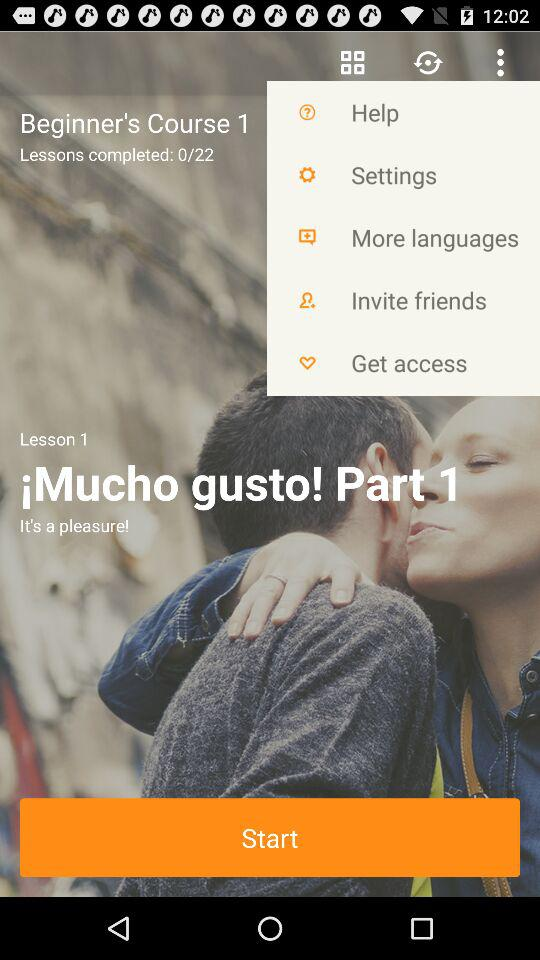How many lessons are there in total?
Answer the question using a single word or phrase. 22 